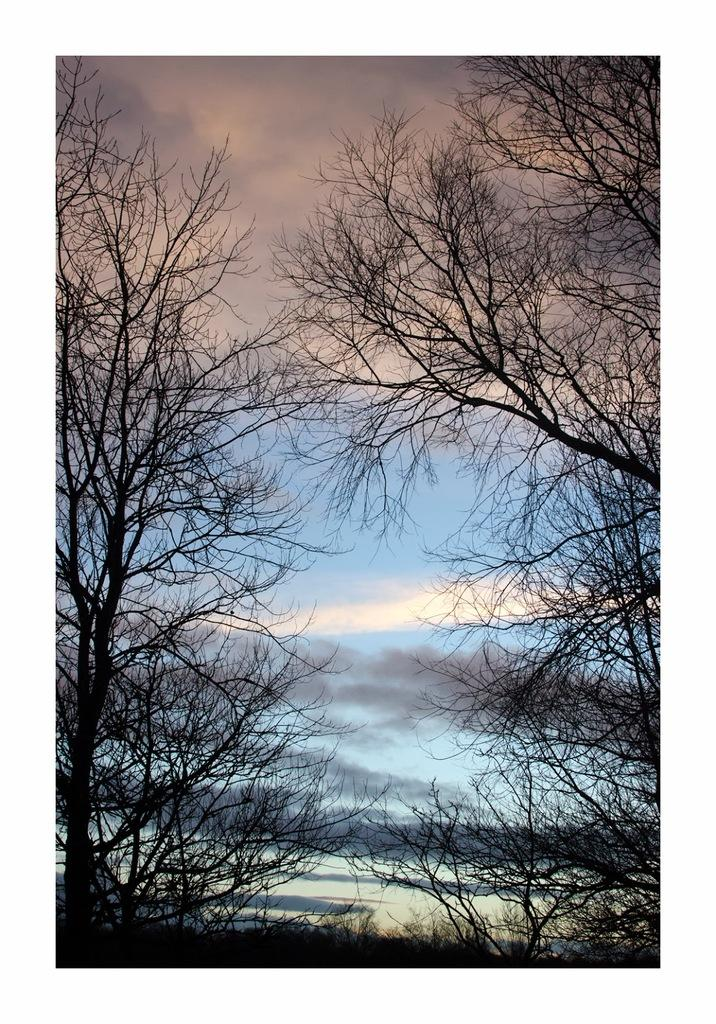What type of vegetation can be seen in the image? There are trees in the image. What part of the natural environment is visible in the image? The sky is visible in the image. What can be observed in the sky? Clouds are present in the sky. What is the taste of the pet in the image? There is no pet present in the image, so it is not possible to determine its taste. 